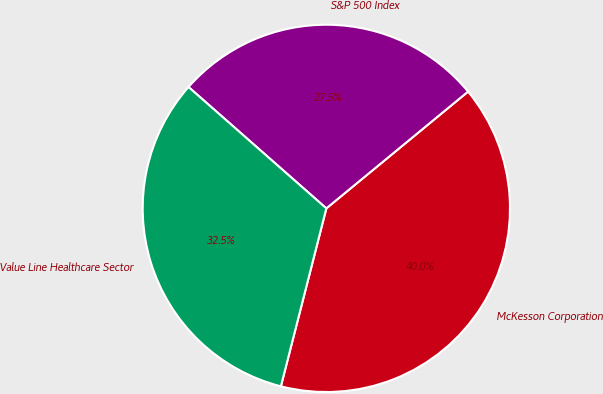<chart> <loc_0><loc_0><loc_500><loc_500><pie_chart><fcel>McKesson Corporation<fcel>S&P 500 Index<fcel>Value Line Healthcare Sector<nl><fcel>39.95%<fcel>27.54%<fcel>32.51%<nl></chart> 